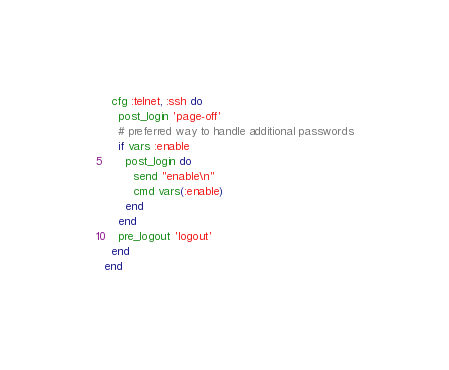Convert code to text. <code><loc_0><loc_0><loc_500><loc_500><_Ruby_>  cfg :telnet, :ssh do
    post_login 'page-off'
    # preferred way to handle additional passwords
    if vars :enable
      post_login do
        send "enable\n"
        cmd vars(:enable)
      end
    end
    pre_logout 'logout'
  end
end
</code> 